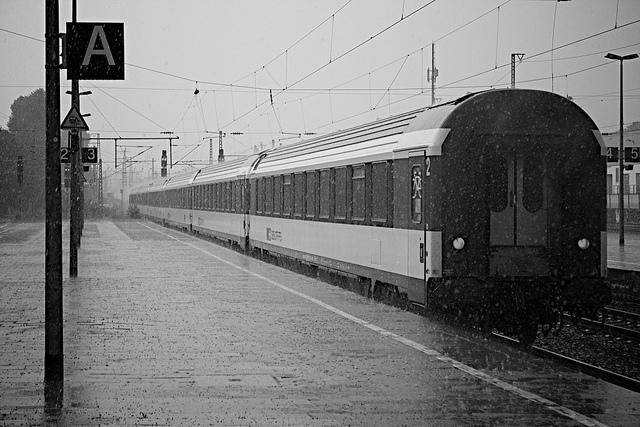What letter is on the sign?
Keep it brief. A. What vehicle is shown in the picture?
Be succinct. Train. Is it raining?
Quick response, please. Yes. 